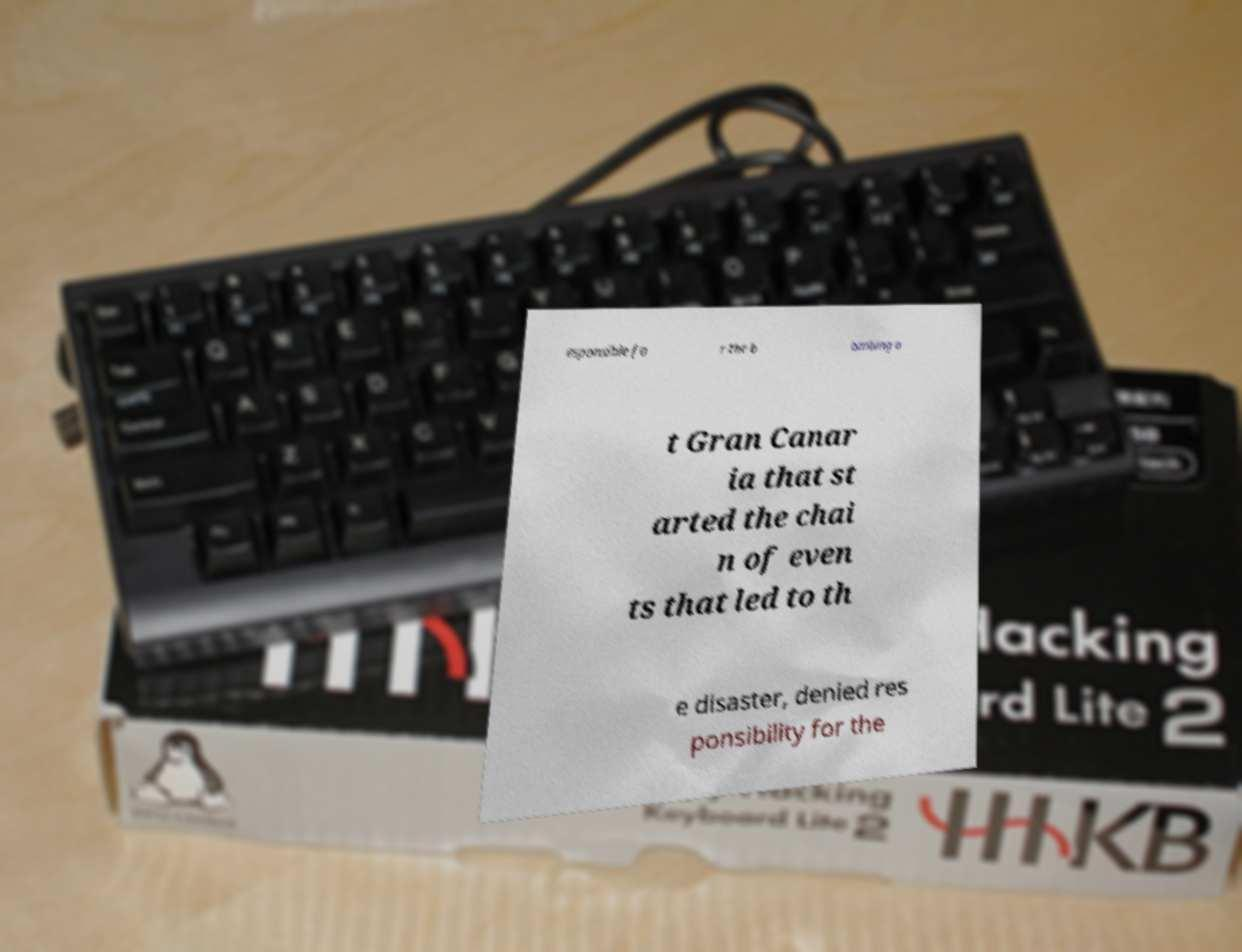I need the written content from this picture converted into text. Can you do that? esponsible fo r the b ombing a t Gran Canar ia that st arted the chai n of even ts that led to th e disaster, denied res ponsibility for the 